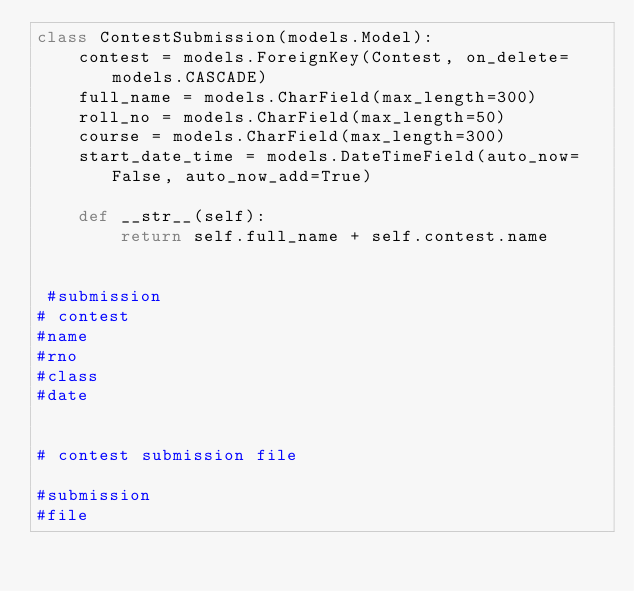Convert code to text. <code><loc_0><loc_0><loc_500><loc_500><_Python_>class ContestSubmission(models.Model):
    contest = models.ForeignKey(Contest, on_delete=models.CASCADE)
    full_name = models.CharField(max_length=300)
    roll_no = models.CharField(max_length=50)
    course = models.CharField(max_length=300)
    start_date_time = models.DateTimeField(auto_now=False, auto_now_add=True)

    def __str__(self):
        return self.full_name + self.contest.name


 #submission
# contest
#name
#rno
#class
#date


# contest submission file

#submission
#file
</code> 